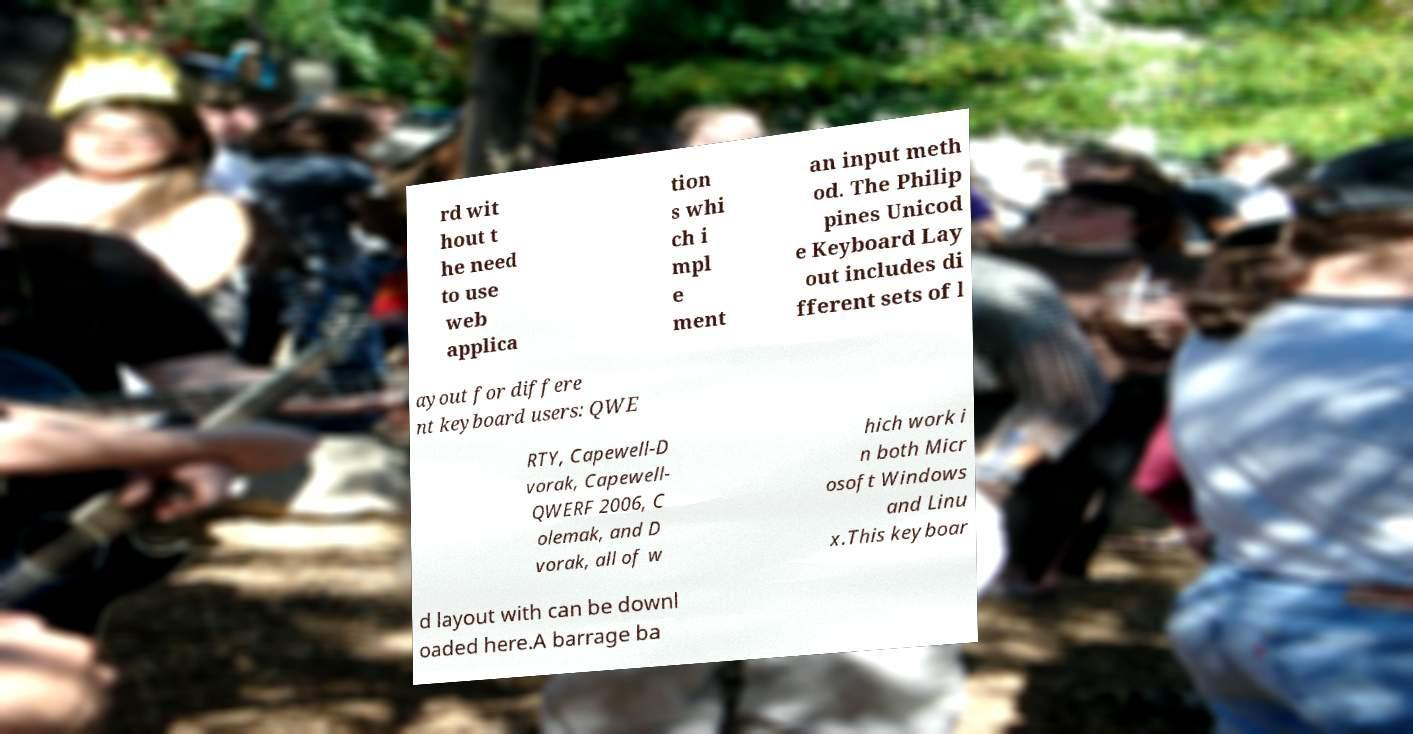Please read and relay the text visible in this image. What does it say? rd wit hout t he need to use web applica tion s whi ch i mpl e ment an input meth od. The Philip pines Unicod e Keyboard Lay out includes di fferent sets of l ayout for differe nt keyboard users: QWE RTY, Capewell-D vorak, Capewell- QWERF 2006, C olemak, and D vorak, all of w hich work i n both Micr osoft Windows and Linu x.This keyboar d layout with can be downl oaded here.A barrage ba 